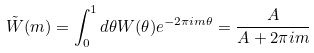<formula> <loc_0><loc_0><loc_500><loc_500>\tilde { W } ( m ) = \int _ { 0 } ^ { 1 } d \theta W ( \theta ) e ^ { - 2 \pi i m \theta } = \frac { A } { A + 2 \pi i m }</formula> 